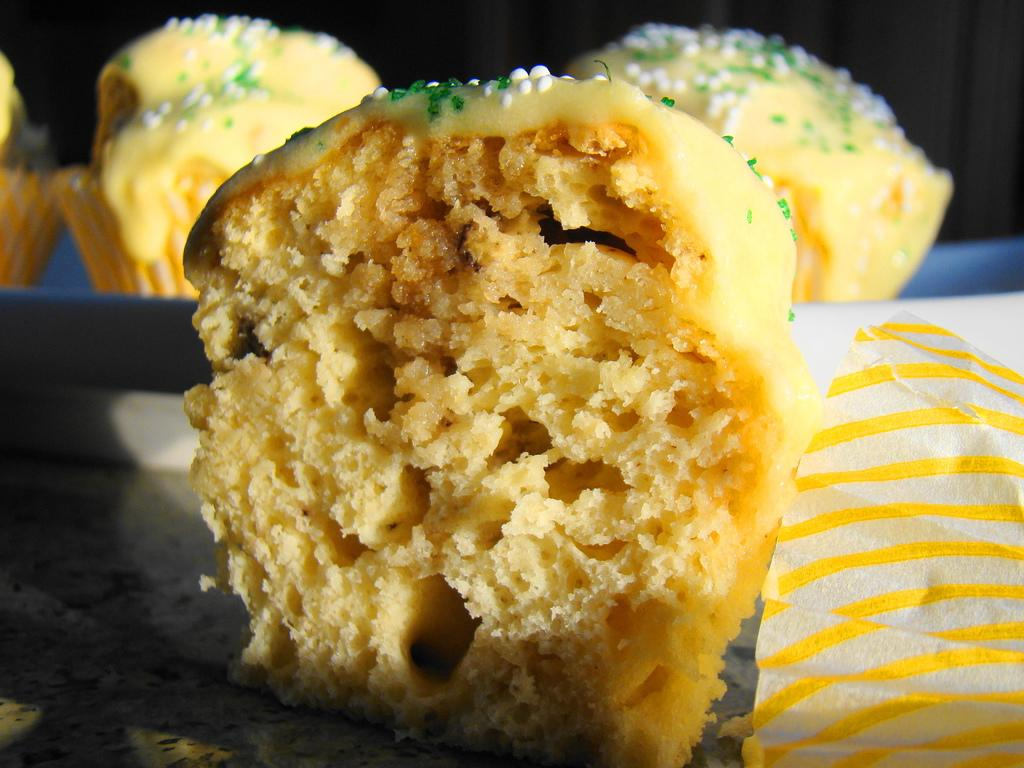What type of baked goods can be seen in the image? There are cupcakes in the image. What color are the cupcakes? The cupcakes are yellow in color. What advice can be seen written on the cupcakes in the image? There is no advice written on the cupcakes in the image; they are simply yellow cupcakes. 